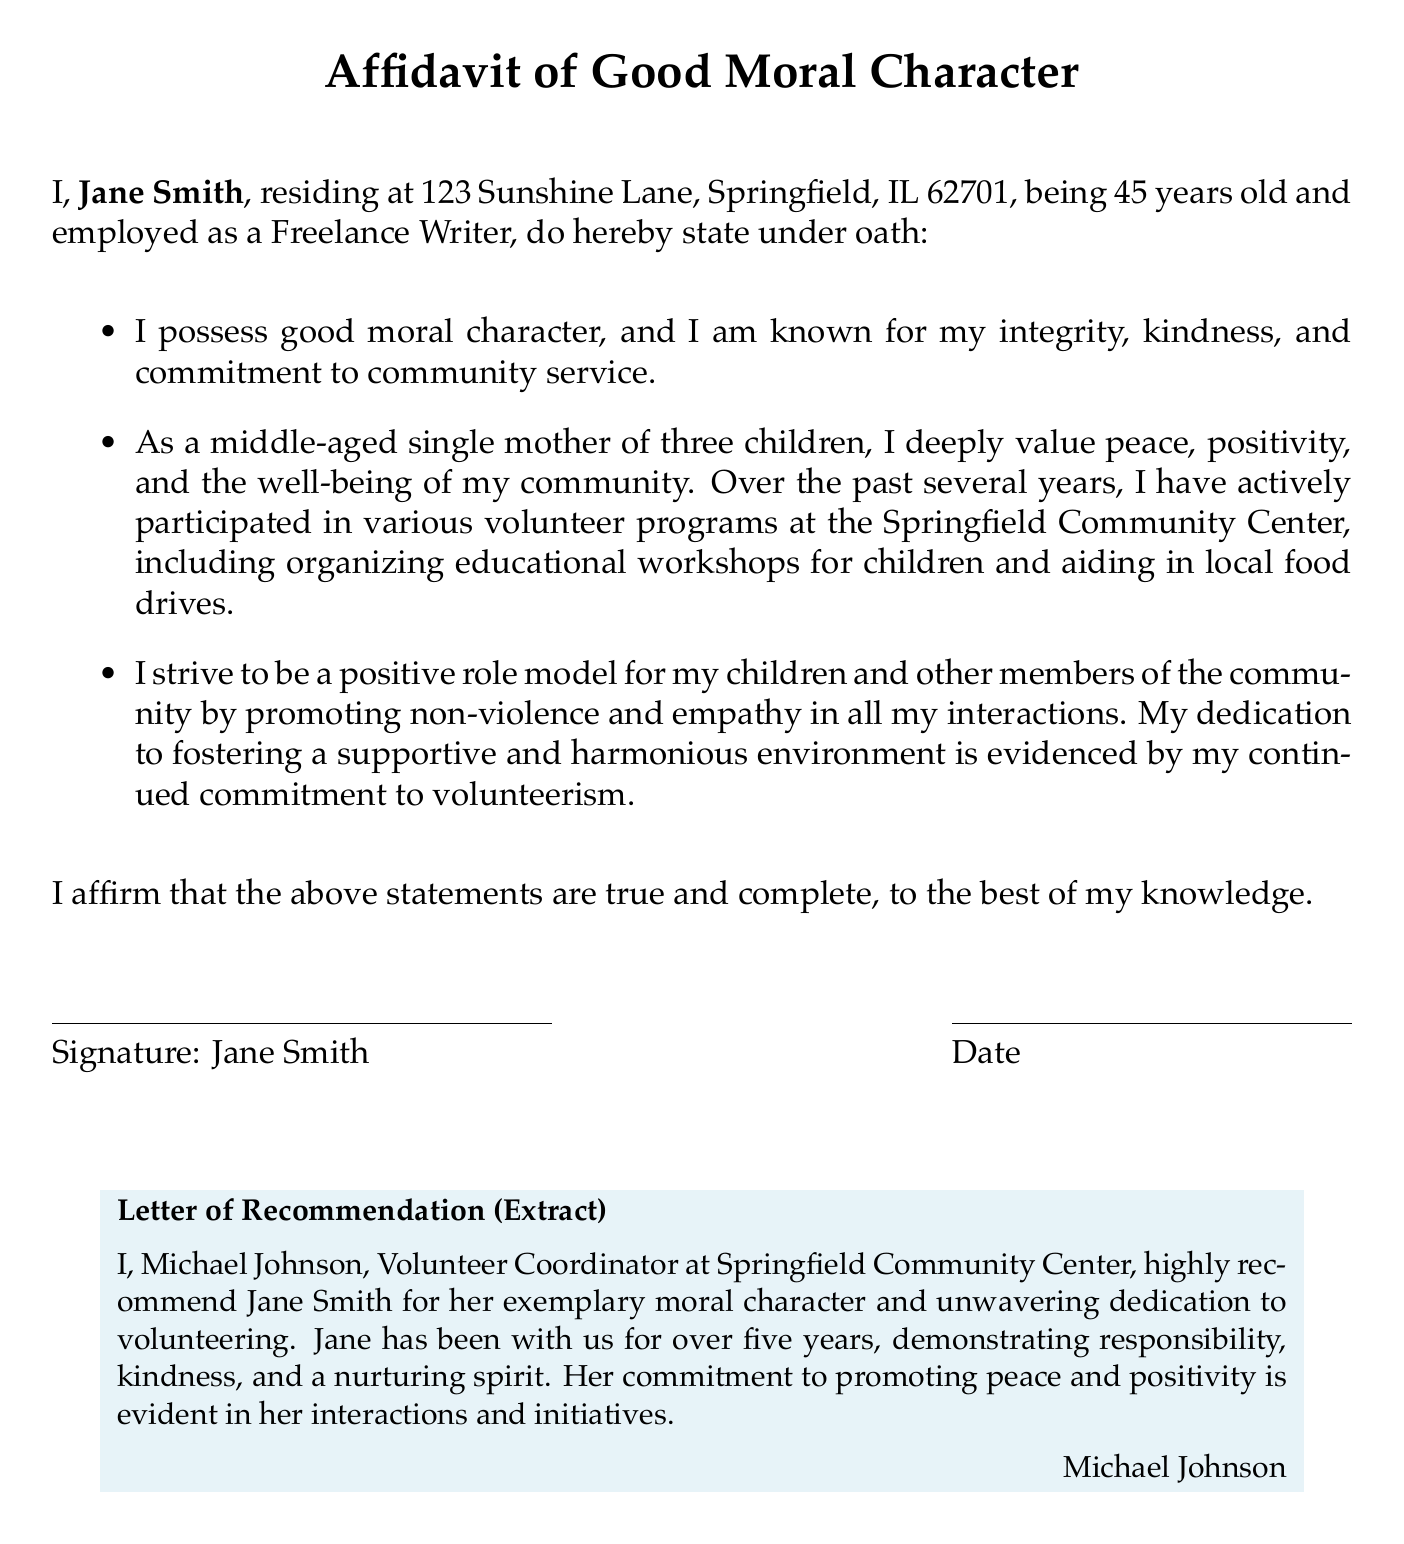What is the name of the affiant? The name of the affiant is prominently mentioned at the beginning of the document, which is Jane Smith.
Answer: Jane Smith What is the address of Jane Smith? The document states Jane Smith's residential address, which is 123 Sunshine Lane, Springfield, IL 62701.
Answer: 123 Sunshine Lane, Springfield, IL 62701 How long has Jane Smith been volunteering at the Springfield Community Center? The affidavit indicates that Jane has been a volunteer for over five years, highlighting her long-term involvement.
Answer: over five years Who is the author of the letter of recommendation? The letter of recommendation is authored by Michael Johnson, who holds the position of Volunteer Coordinator.
Answer: Michael Johnson What is Jane Smith's age? The document specifies that Jane Smith is 45 years old.
Answer: 45 What qualities does Jane Smith emphasize in her affidavit? Jane mentions her integrity, kindness, and commitment to community service as her notable qualities in the affidavit.
Answer: integrity, kindness, commitment to community service What is the main purpose of this affidavit? The primary purpose of the affidavit is to assert Jane Smith's good moral character, particularly in the context of volunteering at the local community center.
Answer: to assert good moral character In what capacity does Jane Smith volunteer? Jane Smith has volunteered to organize educational workshops and aid in local food drives, showcasing her active participation.
Answer: organizing educational workshops, aiding in local food drives What is the tone of Jane Smith's statement about her community values? The tone of her statement reflects a strong emphasis on peace, positivity, and the well-being of the community.
Answer: peace, positivity 